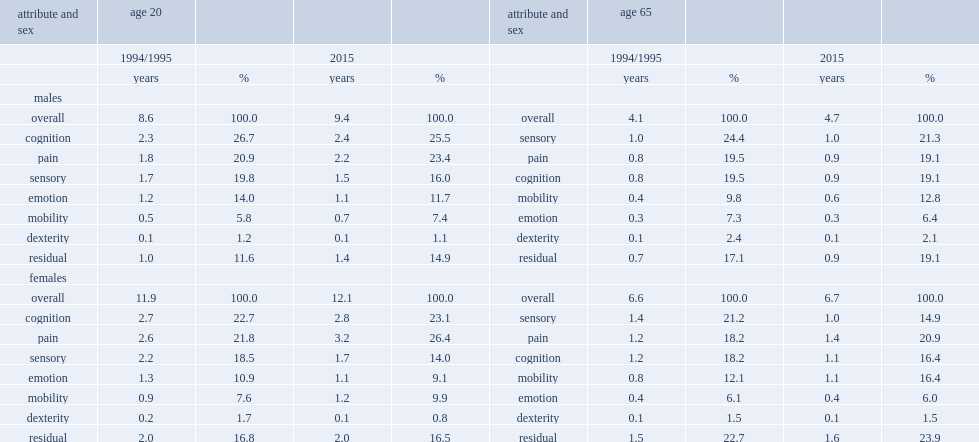In which year was pain a greater source of diminished health for male, 2015 or 1994/1995? 2015.0. In which year was pain a greater source of diminished health for female, 2015 or 1994/1995? 2015.0. 